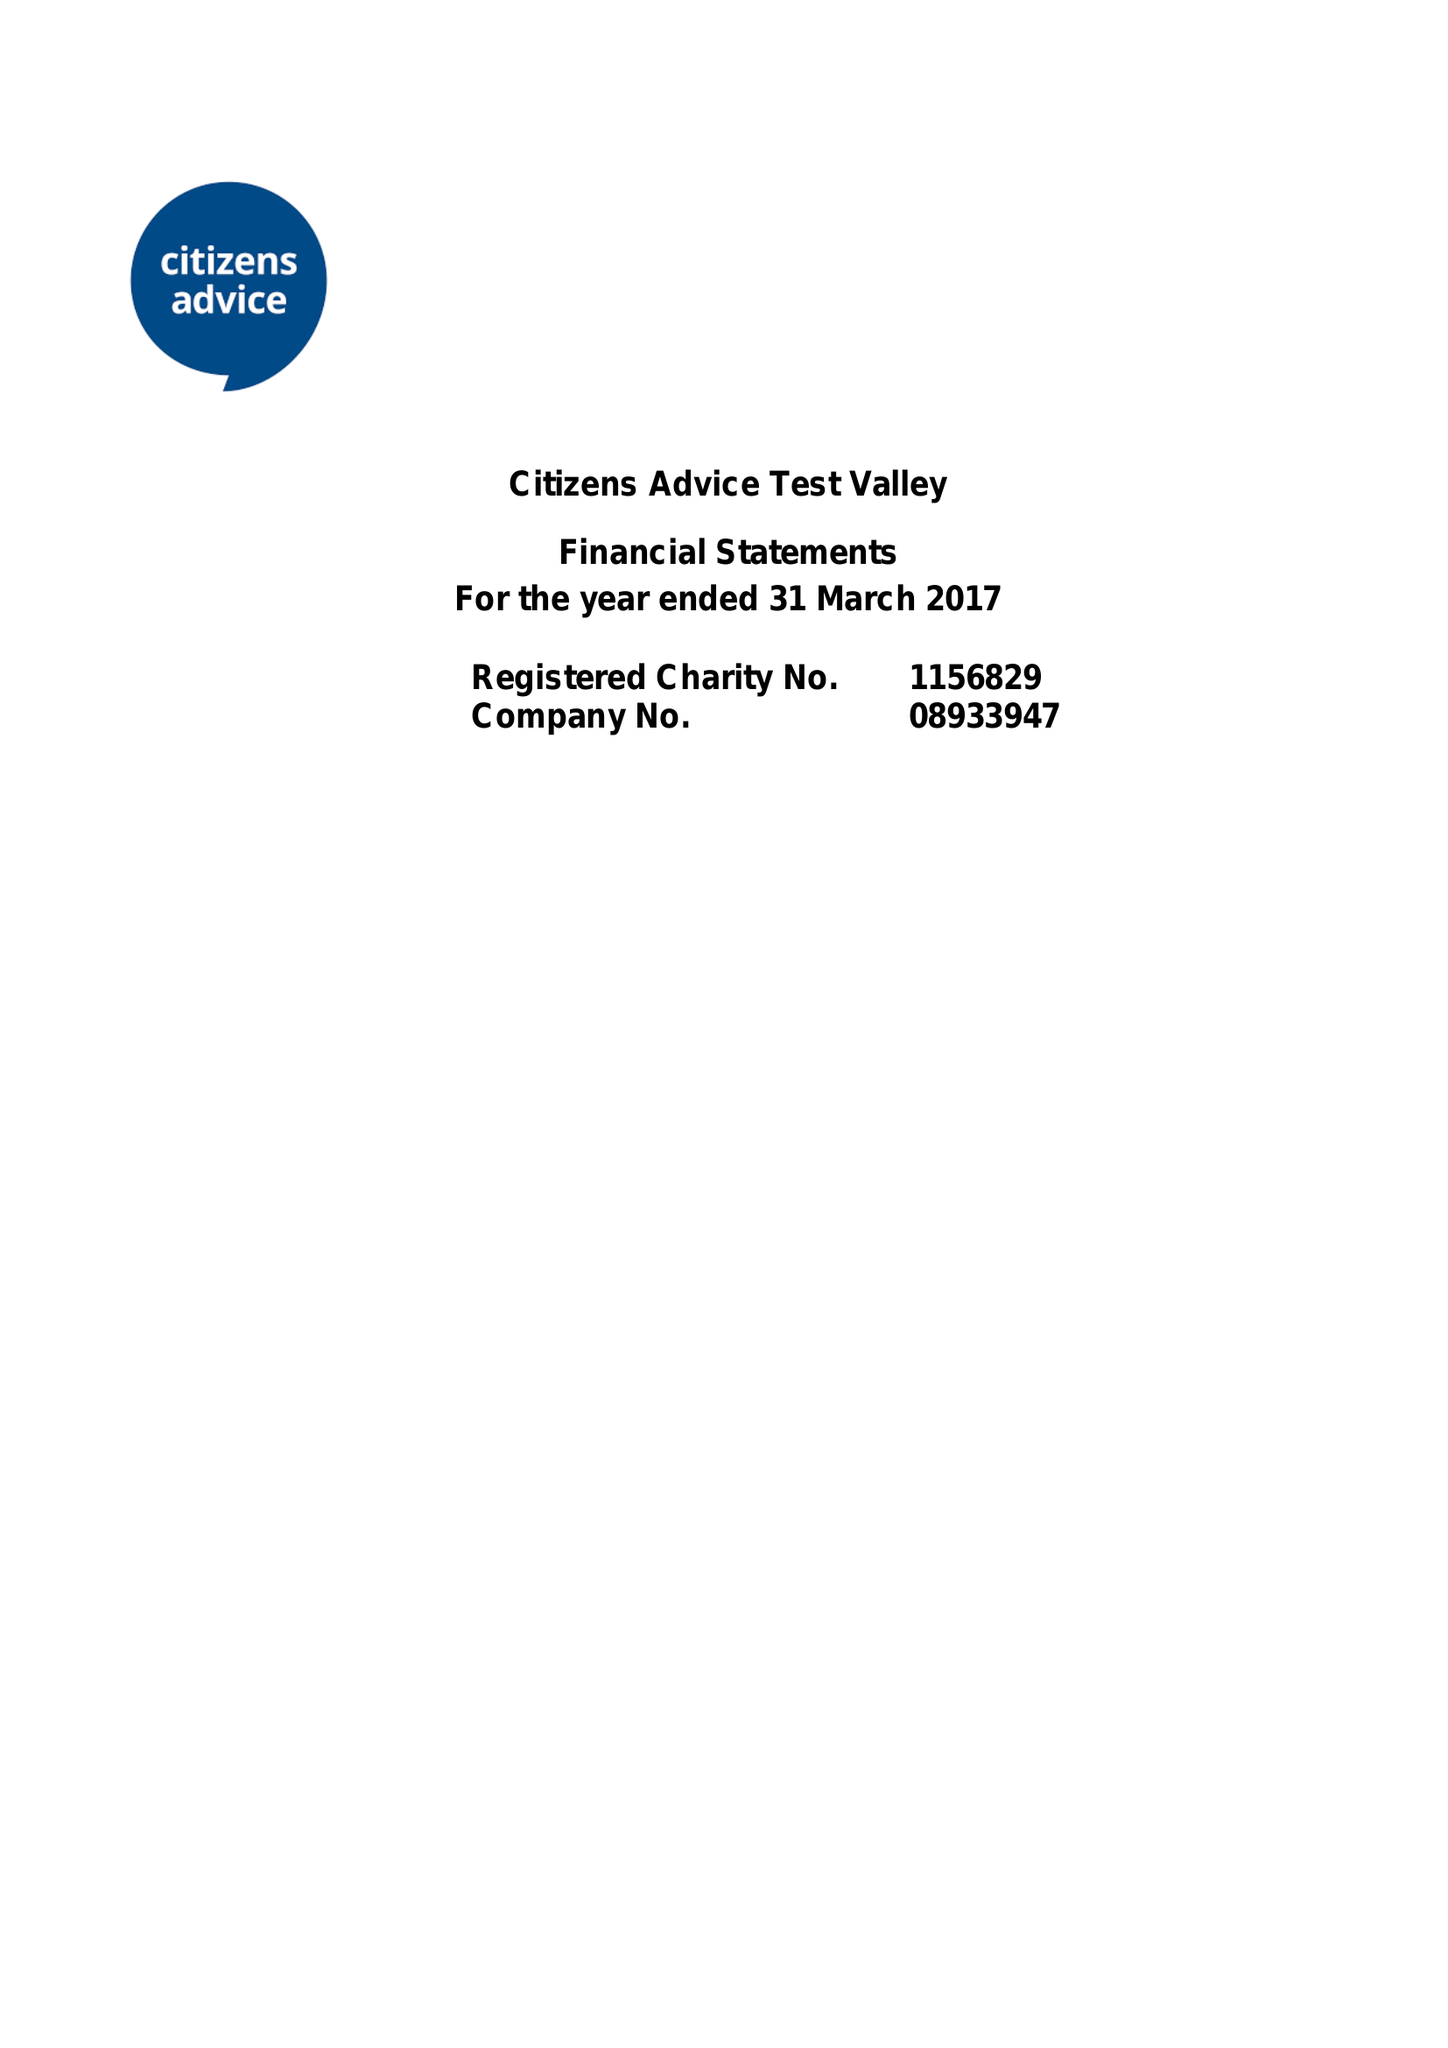What is the value for the charity_name?
Answer the question using a single word or phrase. Test Valley Citizens Advice Bureau 